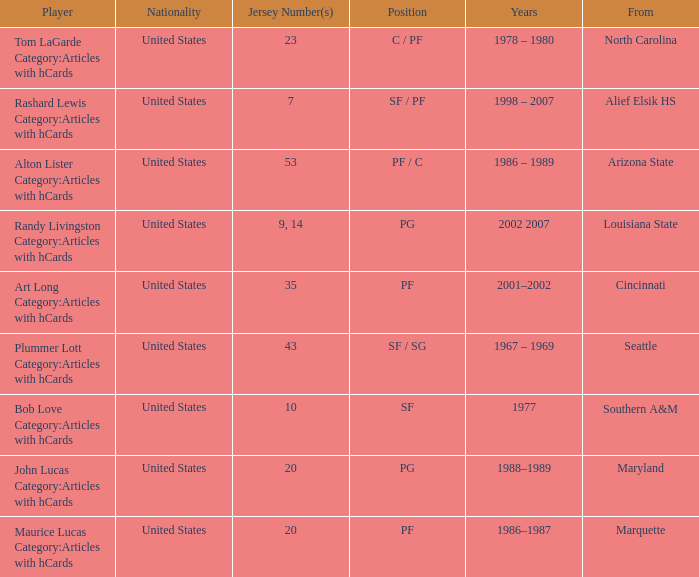Tom Lagarde Category:Articles with hCards used what Jersey Number(s)? 23.0. 